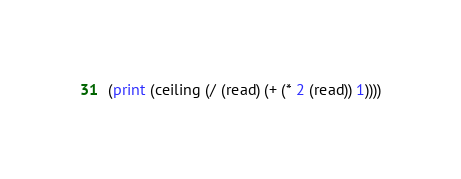<code> <loc_0><loc_0><loc_500><loc_500><_Scheme_>(print (ceiling (/ (read) (+ (* 2 (read)) 1))))</code> 